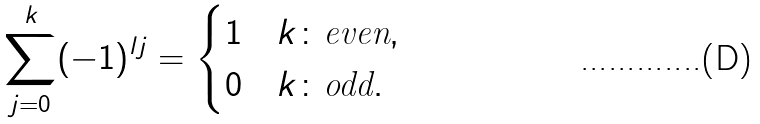<formula> <loc_0><loc_0><loc_500><loc_500>\sum _ { j = 0 } ^ { k } ( - 1 ) ^ { l j } = \begin{cases} 1 & k \colon \text {even} , \\ 0 & k \colon \text {odd} . \end{cases}</formula> 